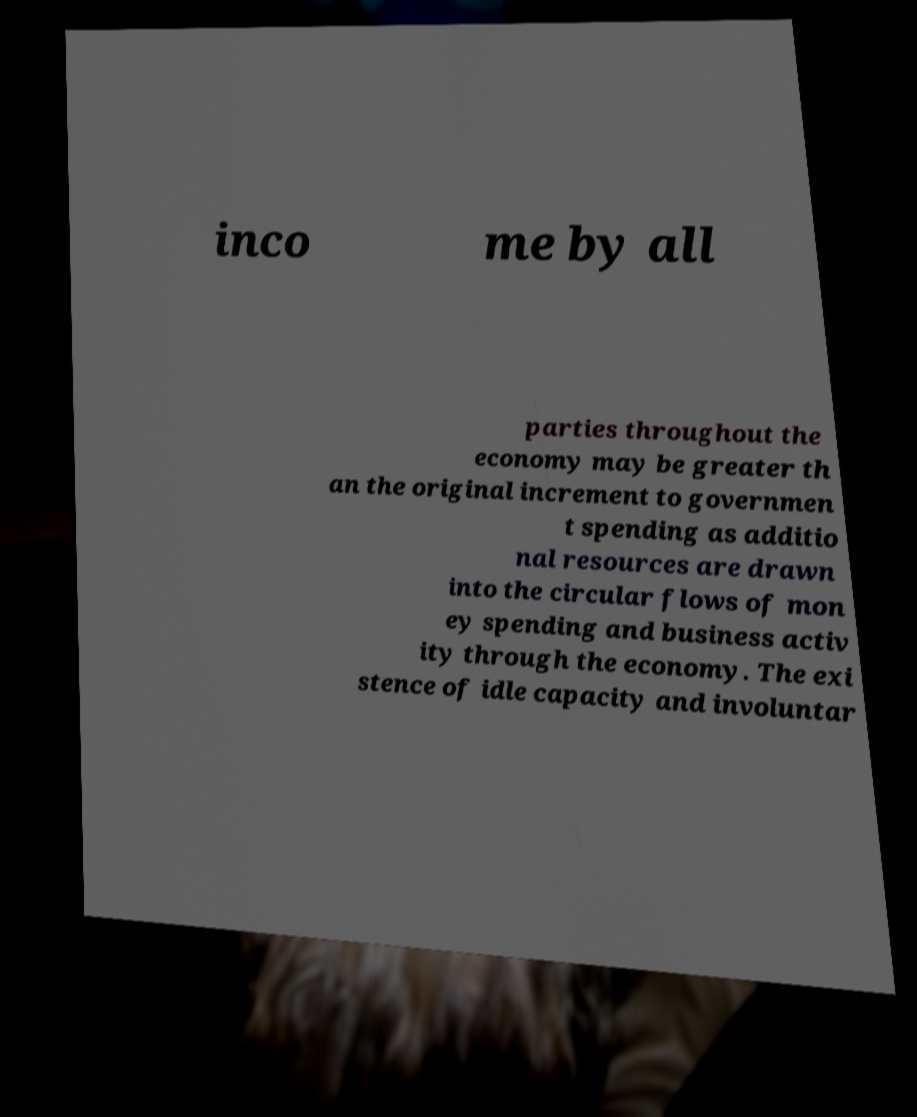For documentation purposes, I need the text within this image transcribed. Could you provide that? inco me by all parties throughout the economy may be greater th an the original increment to governmen t spending as additio nal resources are drawn into the circular flows of mon ey spending and business activ ity through the economy. The exi stence of idle capacity and involuntar 